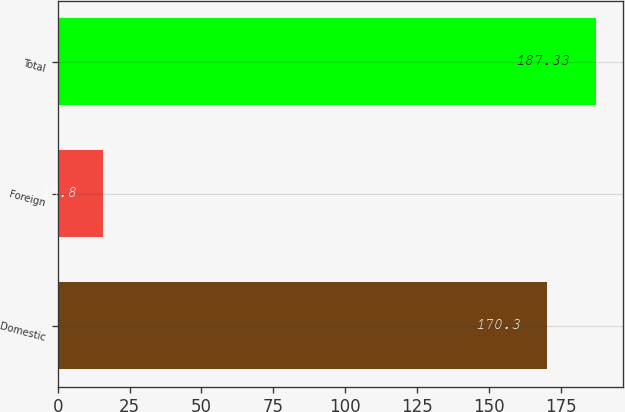Convert chart to OTSL. <chart><loc_0><loc_0><loc_500><loc_500><bar_chart><fcel>Domestic<fcel>Foreign<fcel>Total<nl><fcel>170.3<fcel>15.8<fcel>187.33<nl></chart> 